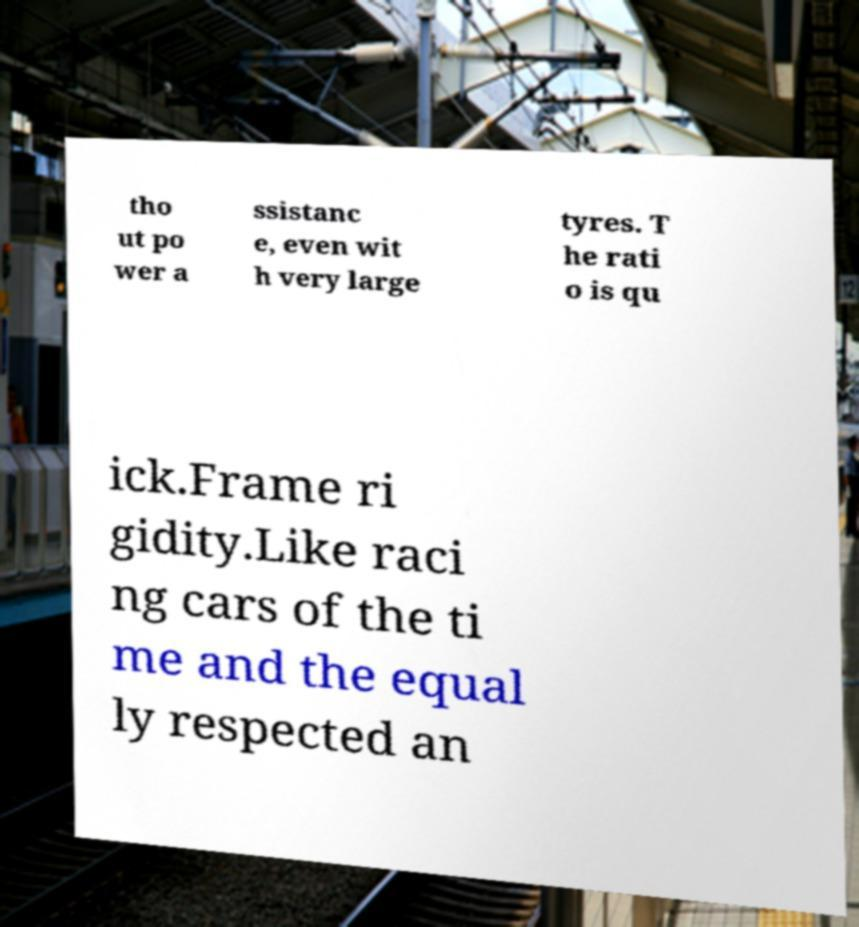Can you accurately transcribe the text from the provided image for me? tho ut po wer a ssistanc e, even wit h very large tyres. T he rati o is qu ick.Frame ri gidity.Like raci ng cars of the ti me and the equal ly respected an 